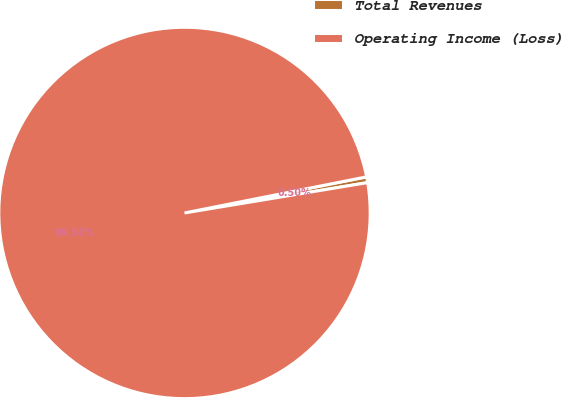<chart> <loc_0><loc_0><loc_500><loc_500><pie_chart><fcel>Total Revenues<fcel>Operating Income (Loss)<nl><fcel>0.5%<fcel>99.5%<nl></chart> 